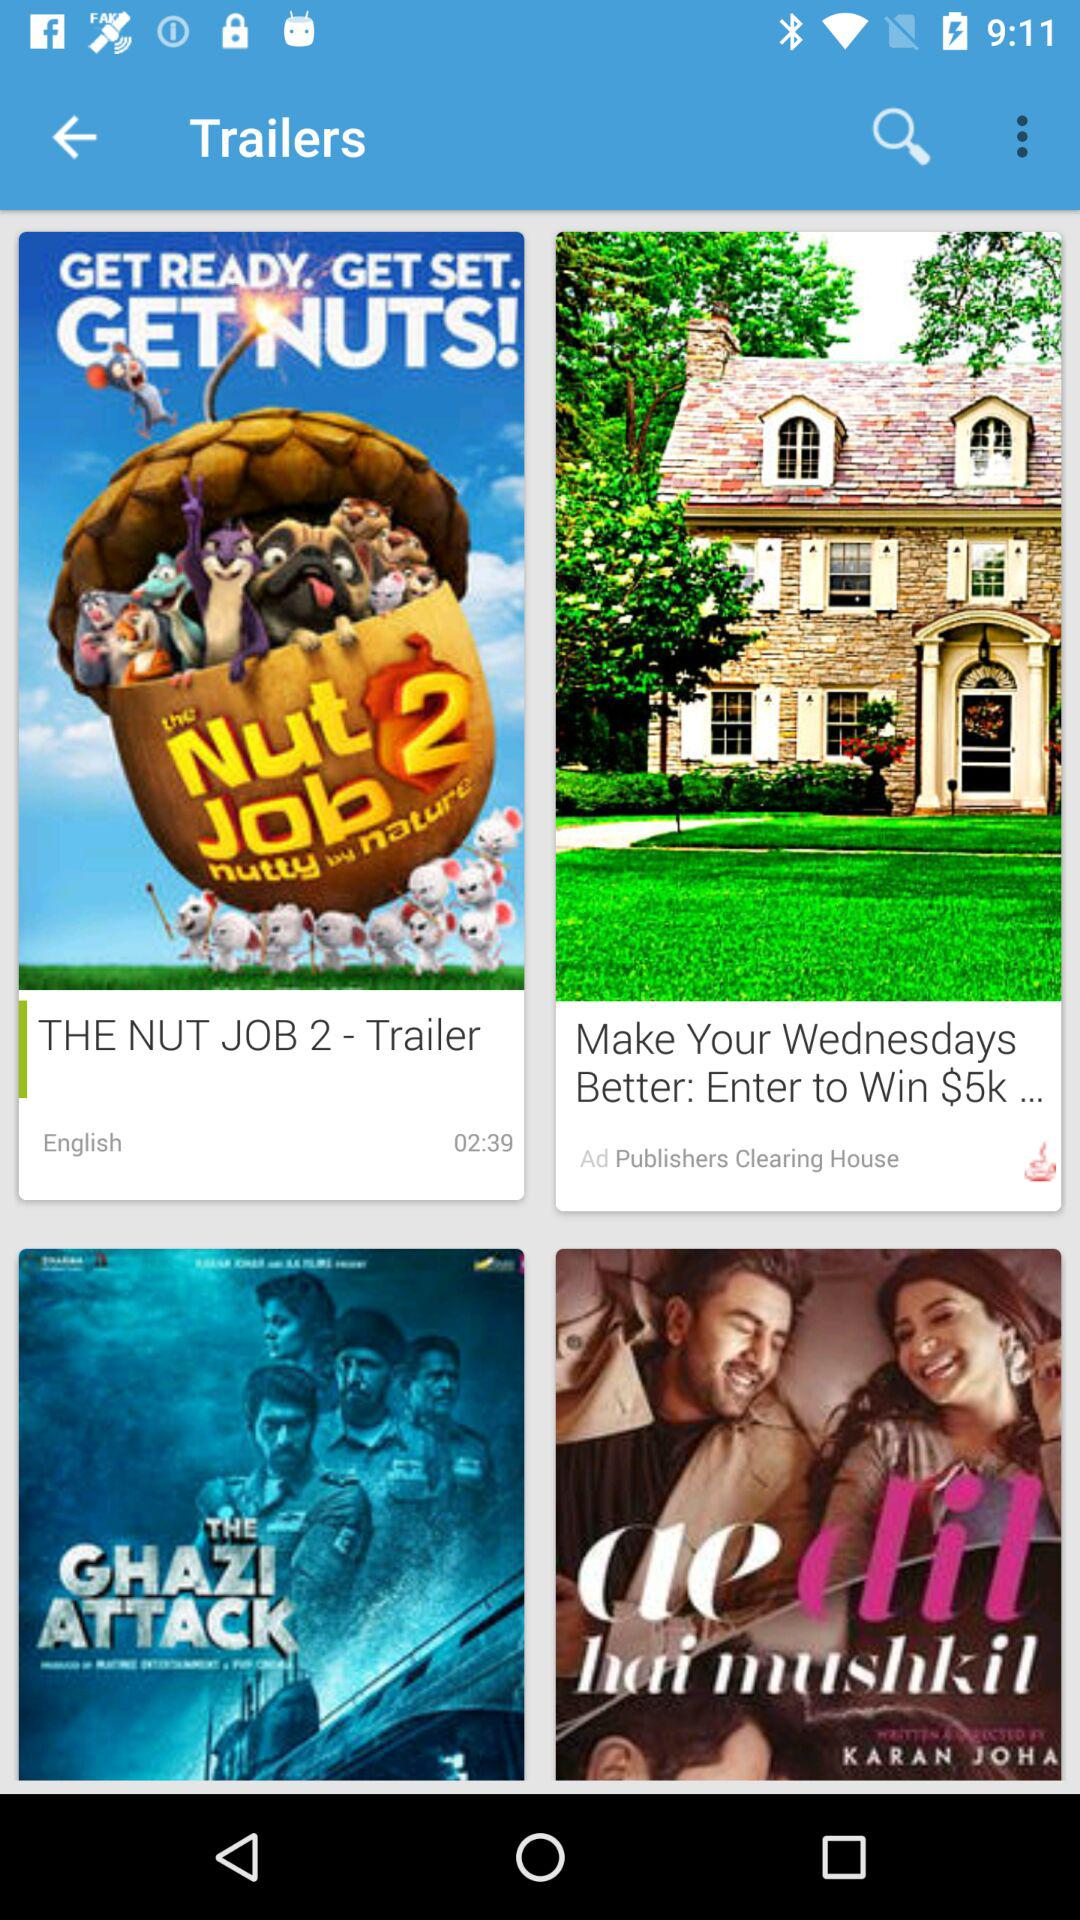In what language is the trailer of "THE NUT JOB 2" released? The language is English. 